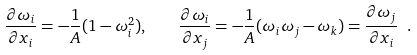<formula> <loc_0><loc_0><loc_500><loc_500>\frac { \partial \omega _ { i } } { \partial x _ { i } } = - \frac { 1 } { A } ( 1 - \omega _ { i } ^ { 2 } ) , \quad \frac { \partial \omega _ { i } } { \partial x _ { j } } = - \frac { 1 } { A } ( \omega _ { i } \omega _ { j } - \omega _ { k } ) = \frac { \partial \omega _ { j } } { \partial x _ { i } } \ .</formula> 